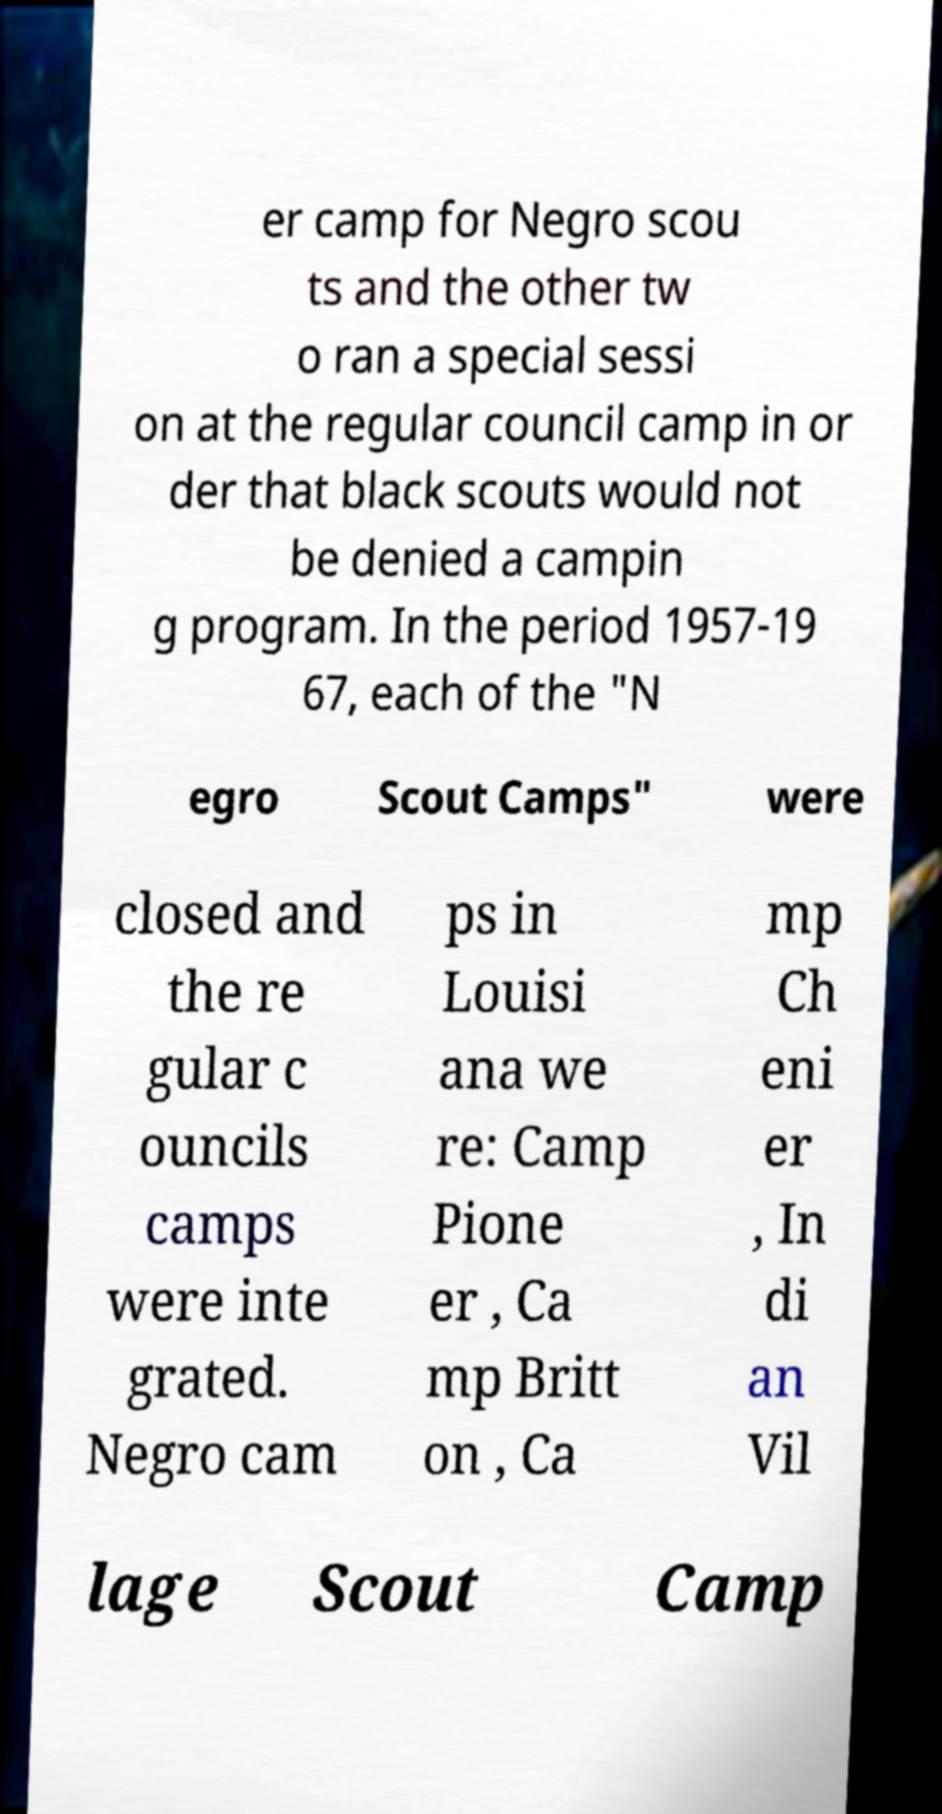Can you read and provide the text displayed in the image?This photo seems to have some interesting text. Can you extract and type it out for me? er camp for Negro scou ts and the other tw o ran a special sessi on at the regular council camp in or der that black scouts would not be denied a campin g program. In the period 1957-19 67, each of the "N egro Scout Camps" were closed and the re gular c ouncils camps were inte grated. Negro cam ps in Louisi ana we re: Camp Pione er , Ca mp Britt on , Ca mp Ch eni er , In di an Vil lage Scout Camp 